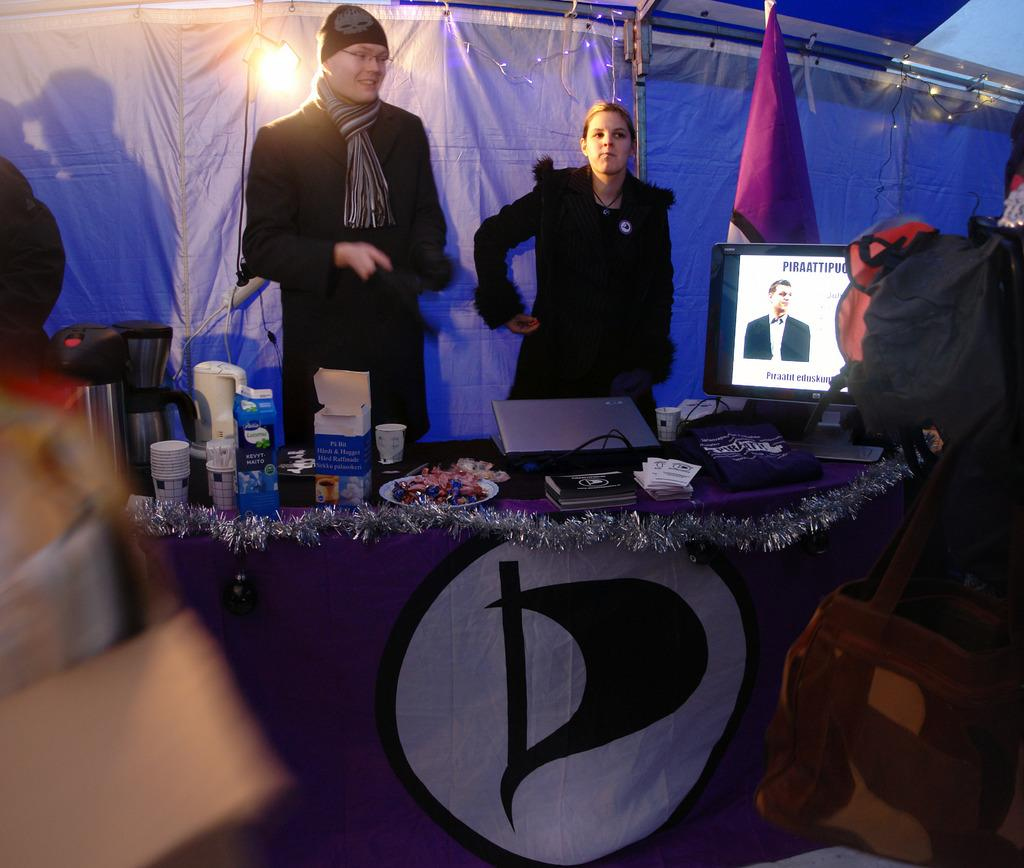What objects are on the table in the image? There are cups, a kettle, a glass jar, food packets, a laptop, and cables on the table in the image. What electronic devices are present on the table? A laptop and a monitor are present on the table. How many people are visible in the image? There are two persons behind the table, and people are visible on both the left and right sides of the image. What can be seen in the background of the image? A cloth and a flag are visible in the background. Can you tell me how many dogs are swimming in the lake in the image? There is no lake or dogs present in the image; it features a table with various objects and people in the background. 